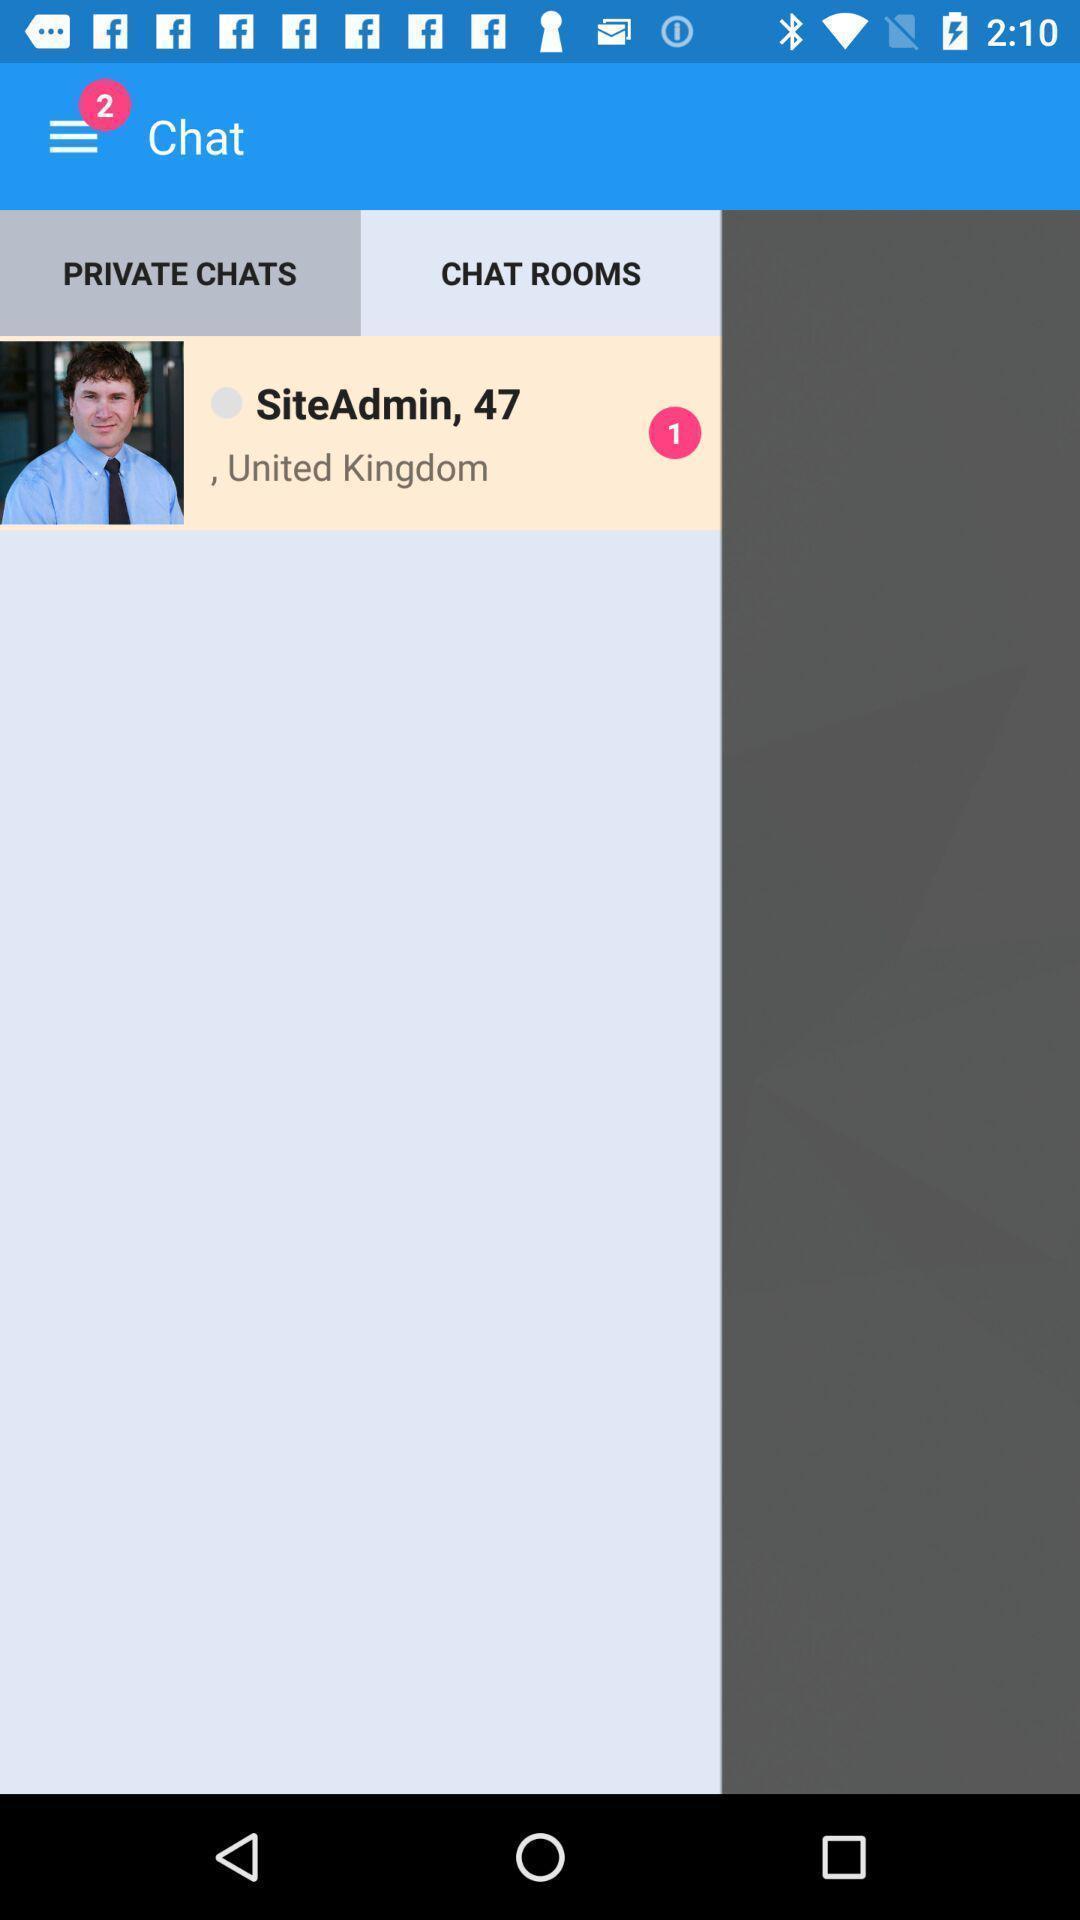Give me a narrative description of this picture. Screen displaying user information and location in a chatting application. 